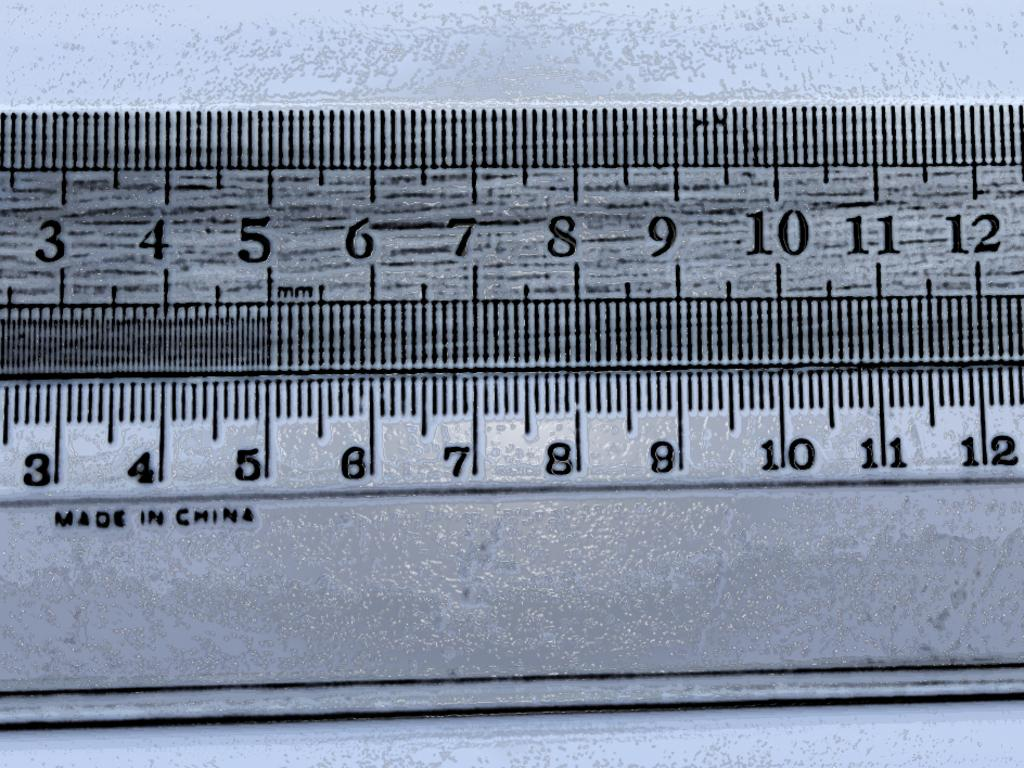<image>
Share a concise interpretation of the image provided. The ruler on the bottom was made in China. 